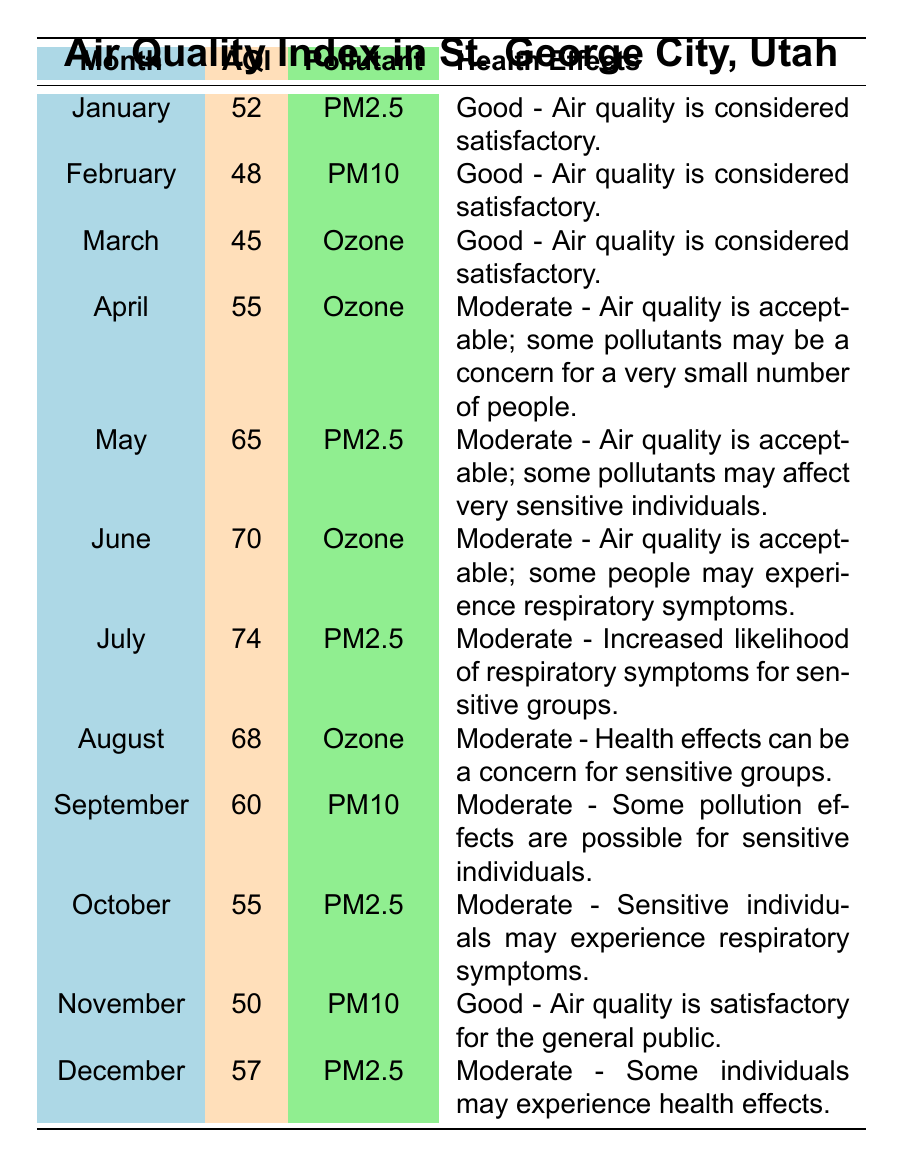What was the highest Air Quality Index (AQI) value recorded in St. George City over the past year? The table shows the AQI for each month. Scanning the AQI values, the highest value can be found in July with a recorded AQI of 74.
Answer: 74 Which month had the lowest average AQI? The average AQI values listed range from 45 to 74. The lowest AQI value is 45, recorded in March.
Answer: March Were there any months classified as having "Good" air quality? The table indicates that the months with "Good" air quality have an AQI below 50. The months of January, February, and March all have AQI values of 52, 48, and 45 respectively, where January and February are also labeled as "Good".
Answer: Yes What is the average AQI for the months categorized as "Moderate"? The months with "Moderate" AQI are April, May, June, July, August, September, October, and December. Their AQI values are: 55, 65, 70, 74, 68, 60, 55, and 57. Summing these gives 55 + 65 + 70 + 74 + 68 + 60 + 55 + 57 = 474. There are 8 months, so the average is 474/8 = 59.25.
Answer: 59.25 Which month had PM2.5 as the primary pollutant? Looking at the data for primary pollutants across each month, PM2.5 is indicated in January, May, July, October, and December. The first occurrence is in January.
Answer: January How many months recorded an AQI above 60? Reviewing the AQI values, they are 52, 48, 45, 55, 65, 70, 74, 68, 60, 55, 50, and 57. The values above 60 are May (65), June (70), July (74), and August (68), counting to a total of 4 months.
Answer: 4 Is ozone ever listed as the primary pollutant in a month with "Good" air quality? The data shows ozone is the primary pollutant in March, which has an AQI of 45, categorized as "Good". Therefore, ozone is indeed associated with a "Good" rating in March.
Answer: Yes Calculate the difference in AQI between the months with the highest and lowest AQI values. The highest AQI is 74 (July) and the lowest is 45 (March). To find the difference, subtract the lowest from the highest: 74 - 45 = 29.
Answer: 29 In which months was PM10 the primary pollutant? Analyzing the data, PM10 appears as the primary pollutant in February, April, and September.
Answer: February, April, September 